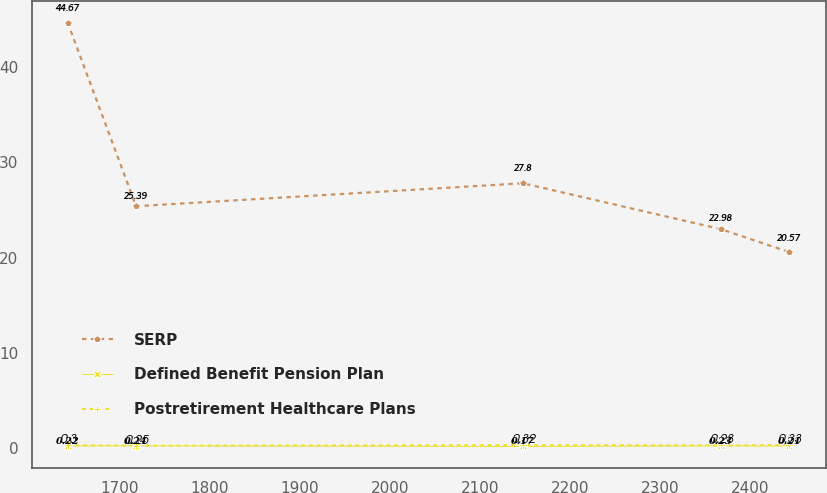Convert chart. <chart><loc_0><loc_0><loc_500><loc_500><line_chart><ecel><fcel>SERP<fcel>Defined Benefit Pension Plan<fcel>Postretirement Healthcare Plans<nl><fcel>1641.78<fcel>44.67<fcel>0.22<fcel>0.3<nl><fcel>1717.89<fcel>25.39<fcel>0.24<fcel>0.25<nl><fcel>2147.94<fcel>27.8<fcel>0.17<fcel>0.32<nl><fcel>2368.13<fcel>22.98<fcel>0.23<fcel>0.28<nl><fcel>2444.24<fcel>20.57<fcel>0.21<fcel>0.33<nl></chart> 